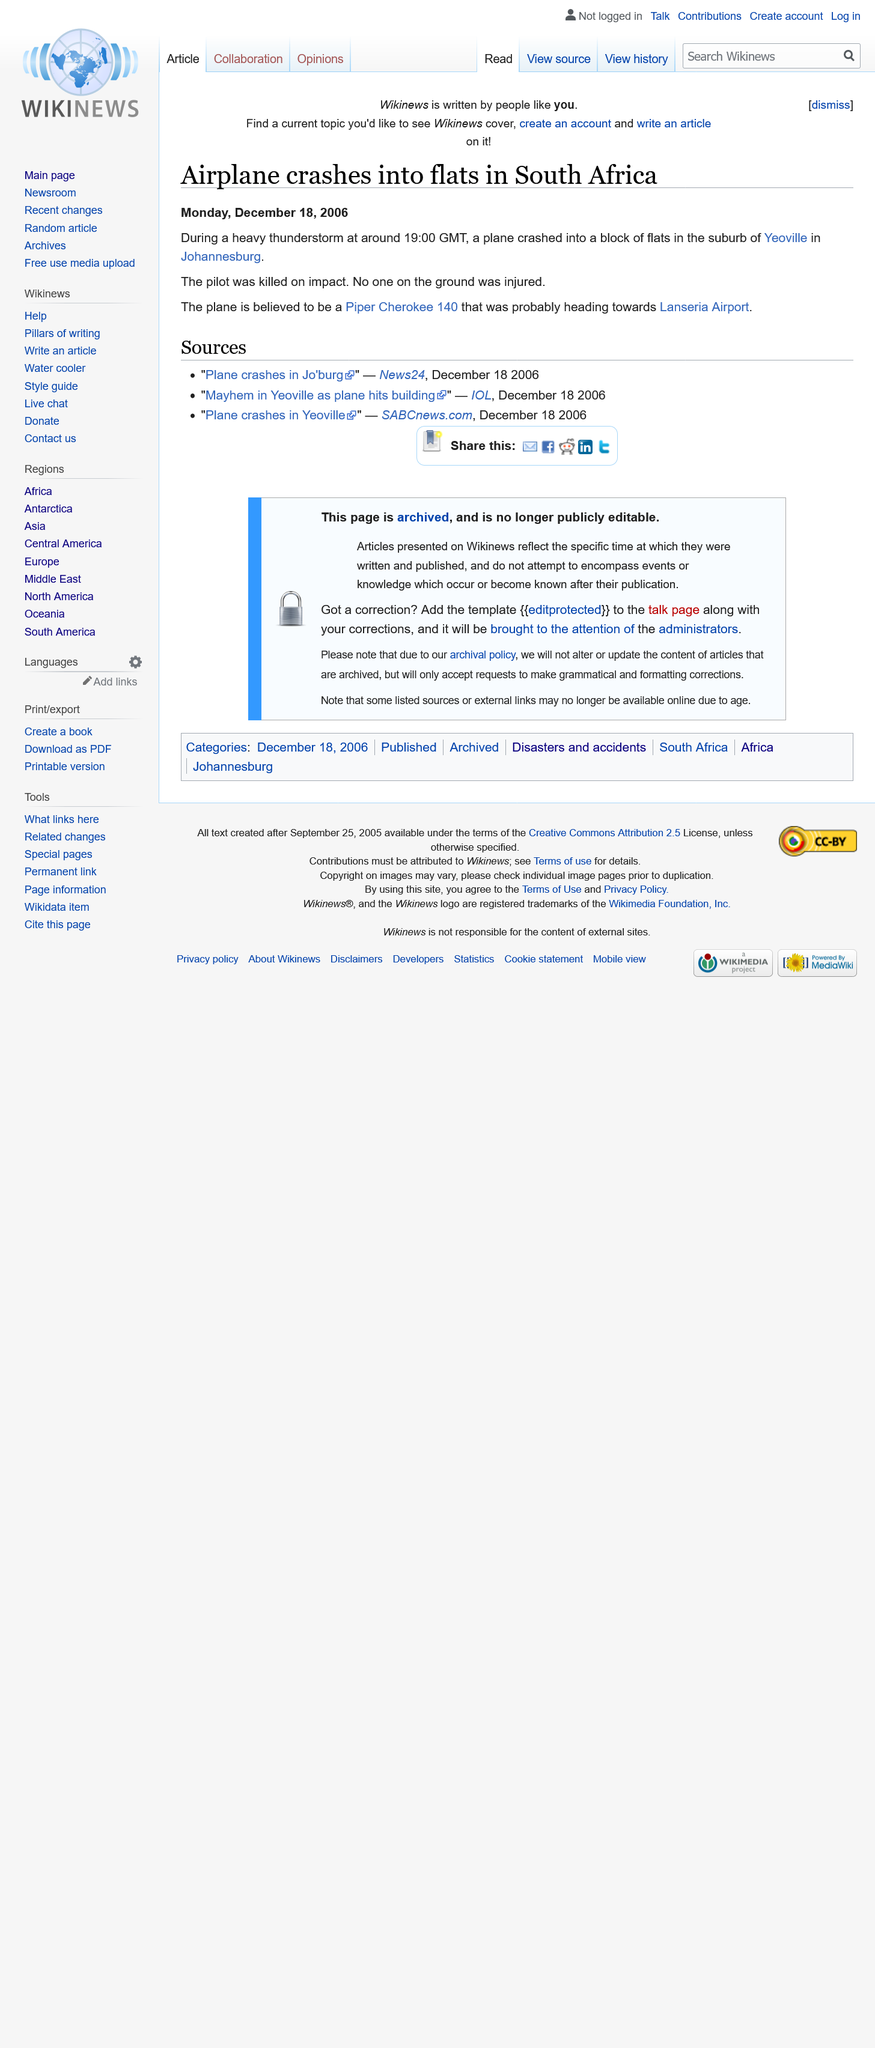Give some essential details in this illustration. On December 18, 2006, the event occurred. The plane crashed in a block of flats located in the suburbs of Yeoville in Johannesburg. It is believed that the plane was headed towards Lanseria Airport. 